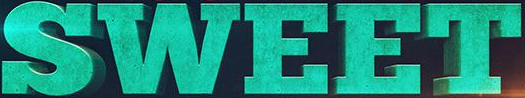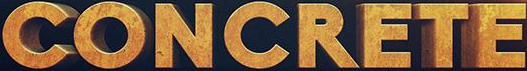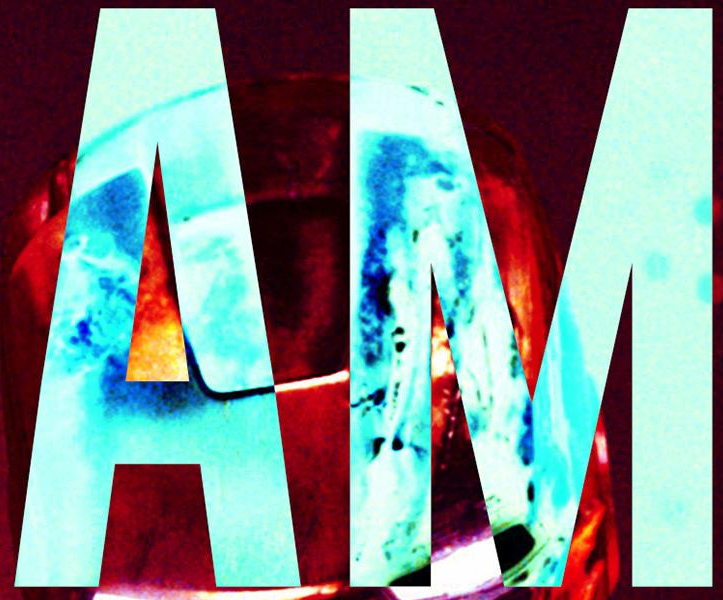What words are shown in these images in order, separated by a semicolon? SWEET; CONCRETE; AM 